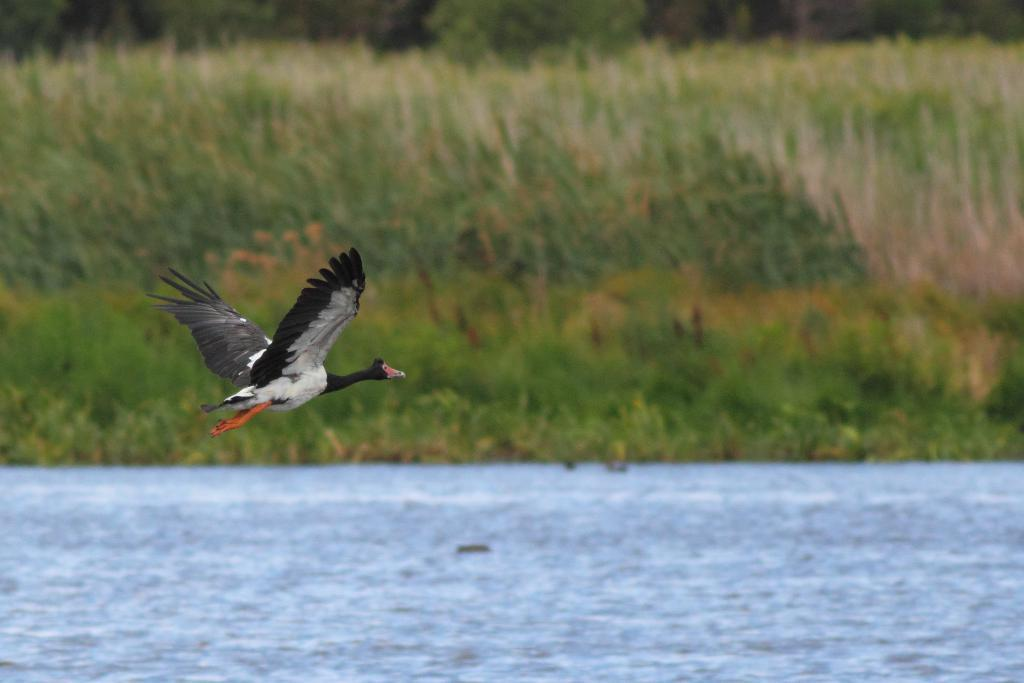What is the bird doing in the image? The bird is flying in the air. What can be seen in the background of the image? There is water visible in the image. What type of vegetation is present in the image? There are plants in the image. What type of jar is the bird holding in the image? There is no jar present in the image; the bird is simply flying in the air. 